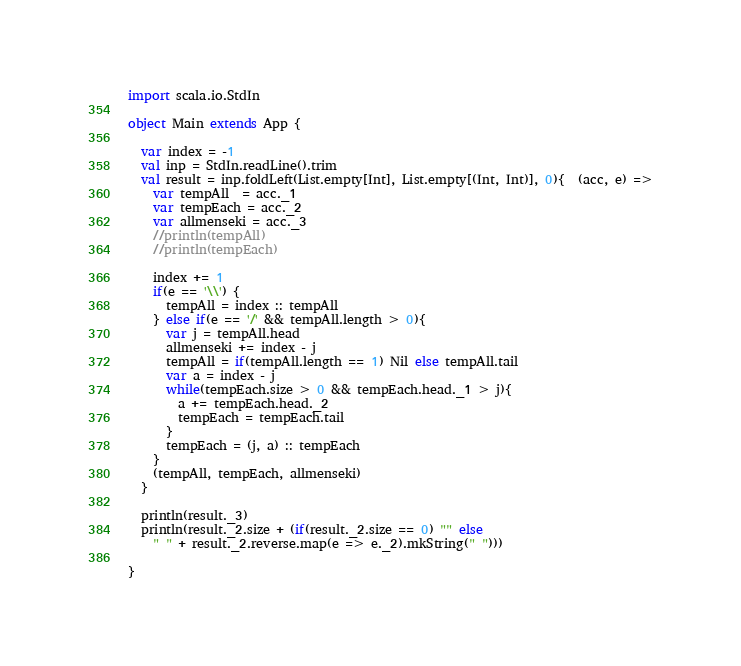<code> <loc_0><loc_0><loc_500><loc_500><_Scala_>import scala.io.StdIn

object Main extends App {
  
  var index = -1
  val inp = StdIn.readLine().trim
  val result = inp.foldLeft(List.empty[Int], List.empty[(Int, Int)], 0){  (acc, e) =>
    var tempAll  = acc._1
    var tempEach = acc._2
    var allmenseki = acc._3
    //println(tempAll)
    //println(tempEach)

    index += 1
    if(e == '\\') {
      tempAll = index :: tempAll  
    } else if(e == '/' && tempAll.length > 0){
      var j = tempAll.head
      allmenseki += index - j
      tempAll = if(tempAll.length == 1) Nil else tempAll.tail
      var a = index - j
      while(tempEach.size > 0 && tempEach.head._1 > j){
        a += tempEach.head._2
        tempEach = tempEach.tail
      }
      tempEach = (j, a) :: tempEach
    }
    (tempAll, tempEach, allmenseki)
  }
  
  println(result._3)
  println(result._2.size + (if(result._2.size == 0) "" else
    " " + result._2.reverse.map(e => e._2).mkString(" ")))
  
}

</code> 